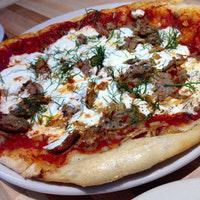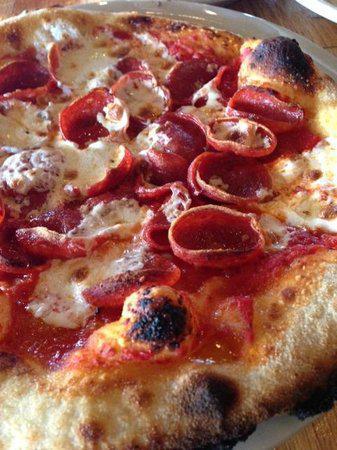The first image is the image on the left, the second image is the image on the right. For the images shown, is this caption "At least one straw is visible in the right image." true? Answer yes or no. No. The first image is the image on the left, the second image is the image on the right. For the images shown, is this caption "The left image shows a pizza that is sliced but no slices are missing, and the right image shows a plate with some slices on it." true? Answer yes or no. No. 